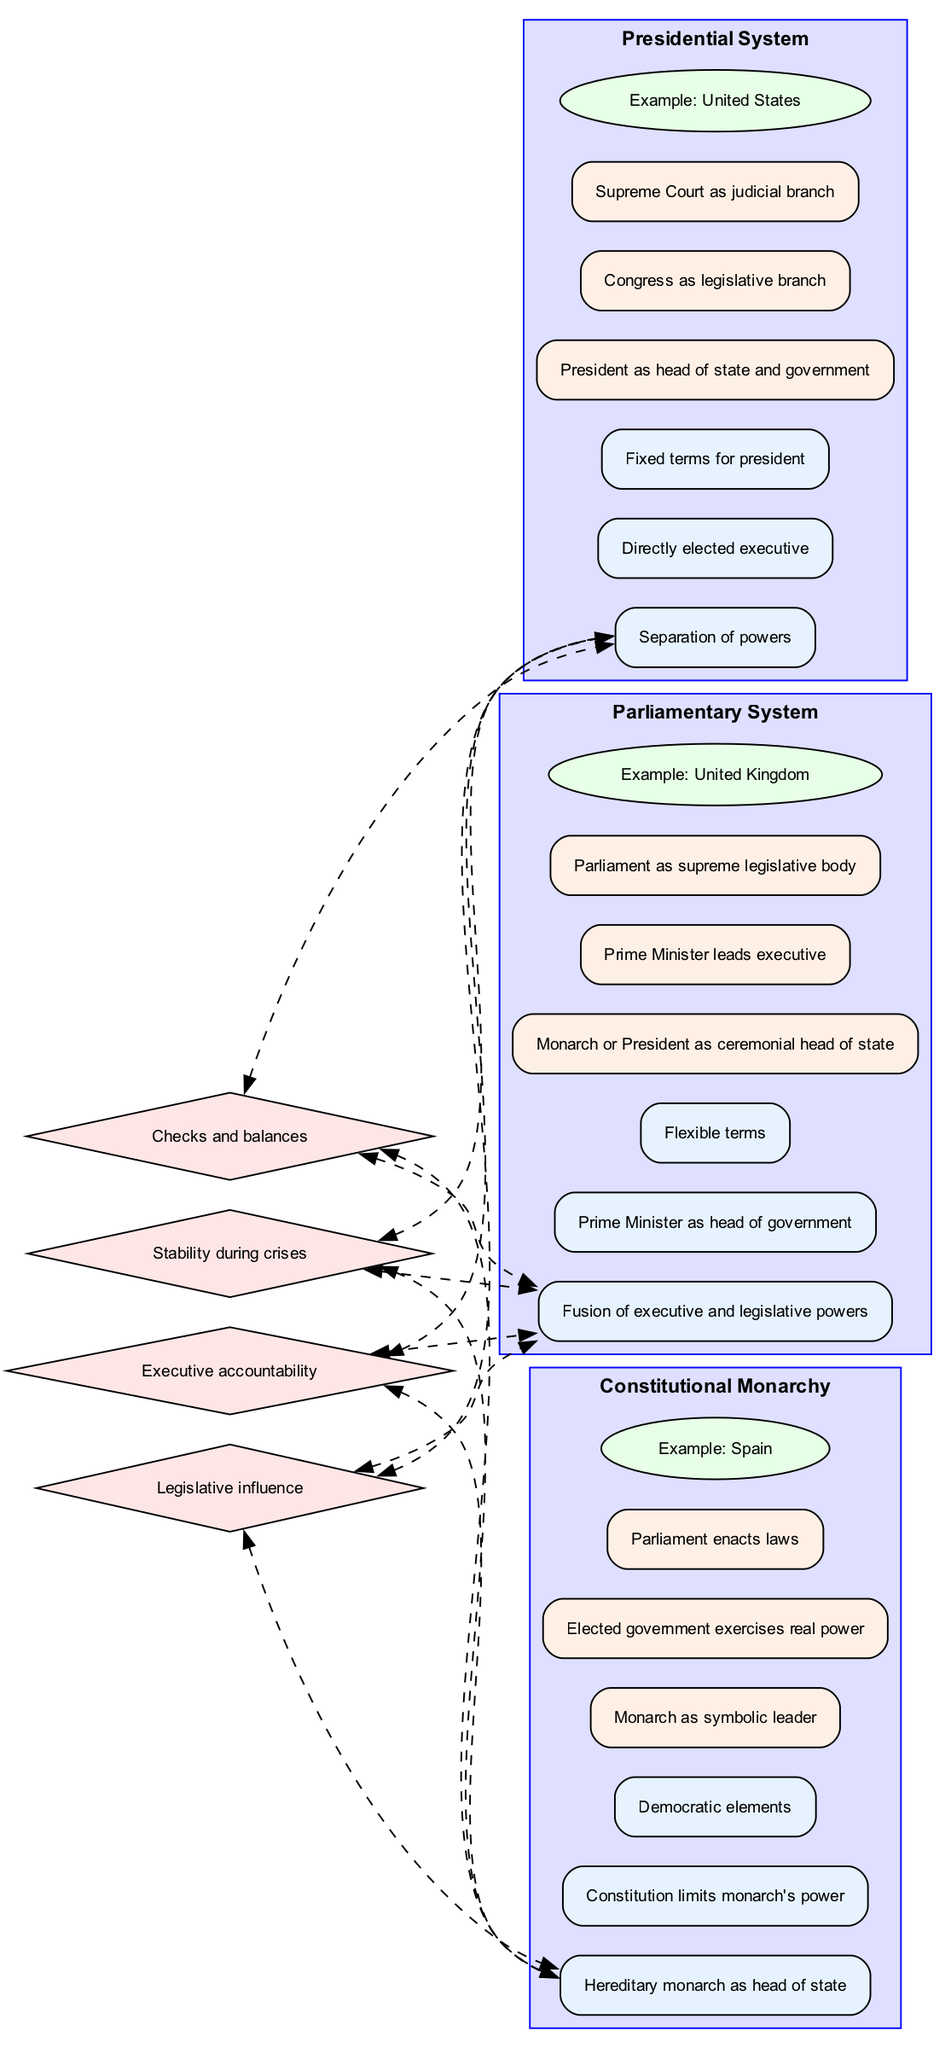What is the example of the Parliamentary System? The node representing the Parliamentary System lists the example as the United Kingdom. By locating the Parliamentary System and examining the corresponding example node, we find that it names the United Kingdom directly.
Answer: United Kingdom What are the fixed terms associated with the Presidential System? The key feature node of the Presidential System states 'Fixed terms for president.' This indicates that in this system, the president has set, unchangeable terms in office.
Answer: Fixed terms for president Which government system has a Prime Minister as the head of government? The Parliamentary System node identifies the Prime Minister as the head of government. Examining the list of key features for this system confirms that the Prime Minister fulfills this role.
Answer: Parliamentary System How many types of government systems are compared in the diagram? The diagram lists three systems: Presidential, Parliamentary, and Constitutional Monarchy. Counting these categorized systems results in a total of three distinct types being compared.
Answer: Three What is the key feature of Constitutional Monarchy that indicates limited power? The node for the key features of Constitutional Monarchy states 'Constitution limits monarch's power.' This clearly identifies the limiting aspect of power within this system's structure.
Answer: Constitution limits monarch's power Which system emphasizes a fusion of executive and legislative powers? The Parliamentary System is described with the feature 'Fusion of executive and legislative powers.' By identifying the key features listed under this system, we can see that this characteristic defines its structure.
Answer: Parliamentary System What comparison point addresses the stability during crises? The comparison points include 'Stability during crises.' This point suggests how various systems might perform or react in times of crisis, as listed along with other power and governance assessments.
Answer: Stability during crises Which government structure is characterized by a symbolic leader with real power exercised by an elected government? The power structure for Constitutional Monarchy notes that there is a 'Monarch as symbolic leader' while 'Elected government exercises real power.' This indicates the division of functions within this system.
Answer: Constitutional Monarchy What type of edge connects the comparison points to the features of each government system? The edges are described as 'dashed,' indicating that this style is used to connect the comparison points to the features for each system, suggesting an evaluative relationship between them.
Answer: Dashed 